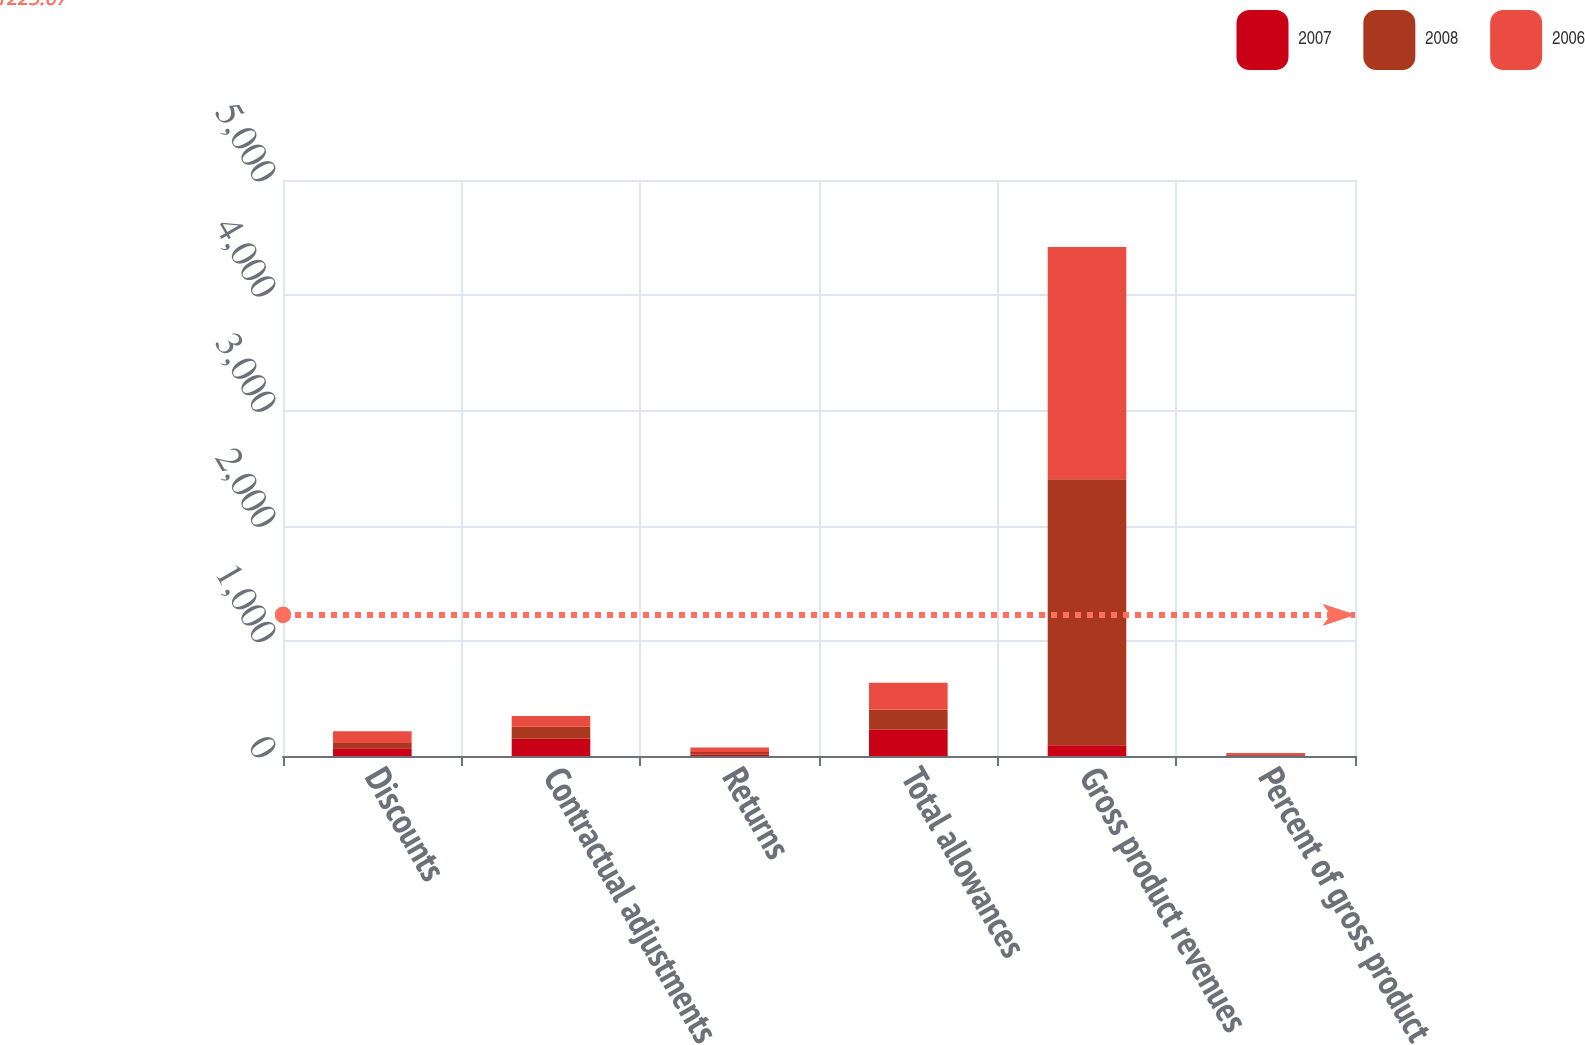Convert chart. <chart><loc_0><loc_0><loc_500><loc_500><stacked_bar_chart><ecel><fcel>Discounts<fcel>Contractual adjustments<fcel>Returns<fcel>Total allowances<fcel>Gross product revenues<fcel>Percent of gross product<nl><fcel>2007<fcel>67.1<fcel>149<fcel>12.2<fcel>228.3<fcel>93.3<fcel>7.4<nl><fcel>2008<fcel>45.7<fcel>105.2<fcel>22.1<fcel>173<fcel>2309.8<fcel>7.5<nl><fcel>2006<fcel>102.9<fcel>93.3<fcel>38.7<fcel>234.9<fcel>2016.2<fcel>11.7<nl></chart> 